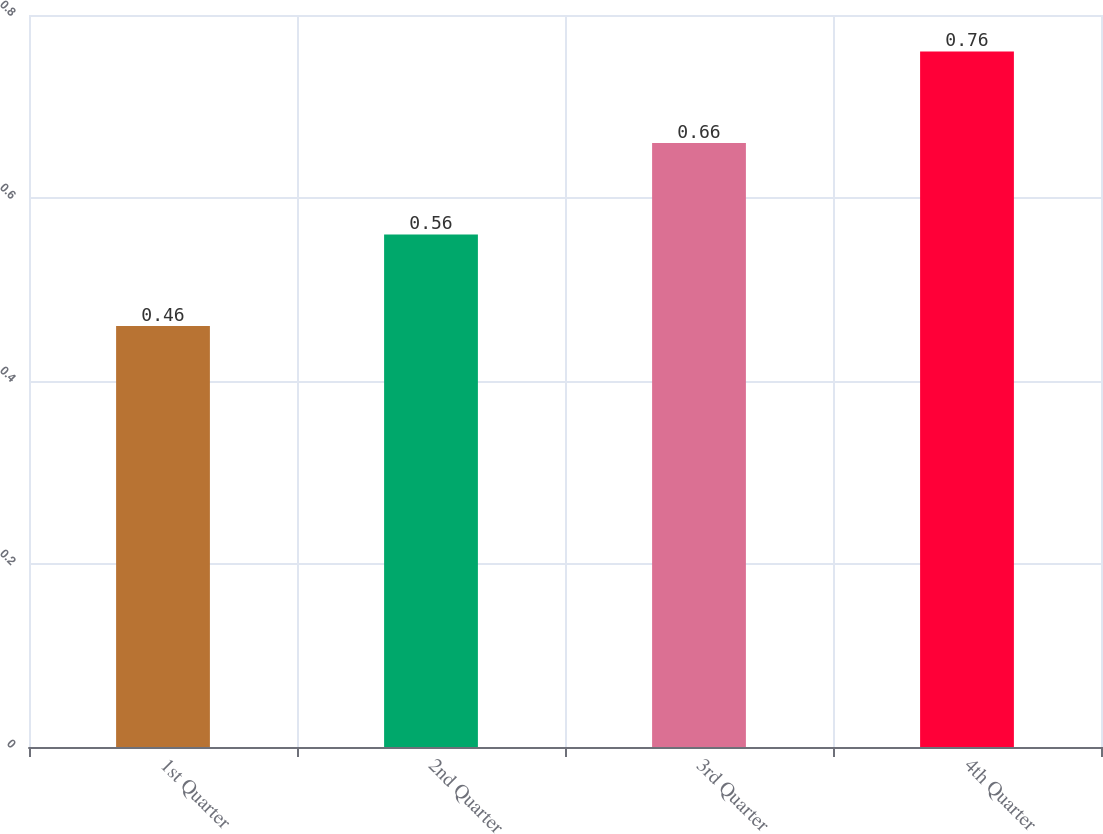Convert chart. <chart><loc_0><loc_0><loc_500><loc_500><bar_chart><fcel>1st Quarter<fcel>2nd Quarter<fcel>3rd Quarter<fcel>4th Quarter<nl><fcel>0.46<fcel>0.56<fcel>0.66<fcel>0.76<nl></chart> 